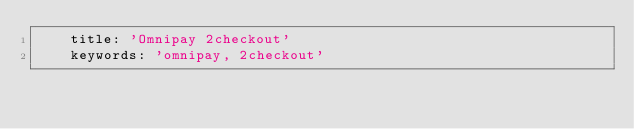Convert code to text. <code><loc_0><loc_0><loc_500><loc_500><_YAML_>    title: 'Omnipay 2checkout'
    keywords: 'omnipay, 2checkout'
</code> 